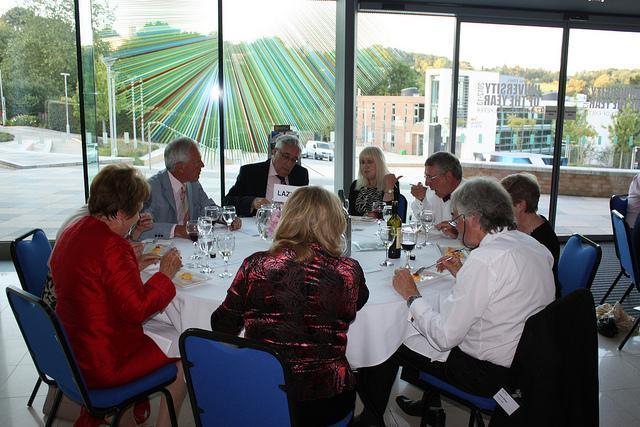How many glass panels are there?
Give a very brief answer. 6. How many chairs are there?
Give a very brief answer. 3. How many people are there?
Give a very brief answer. 8. How many dining tables are there?
Give a very brief answer. 1. How many zebra near from tree?
Give a very brief answer. 0. 